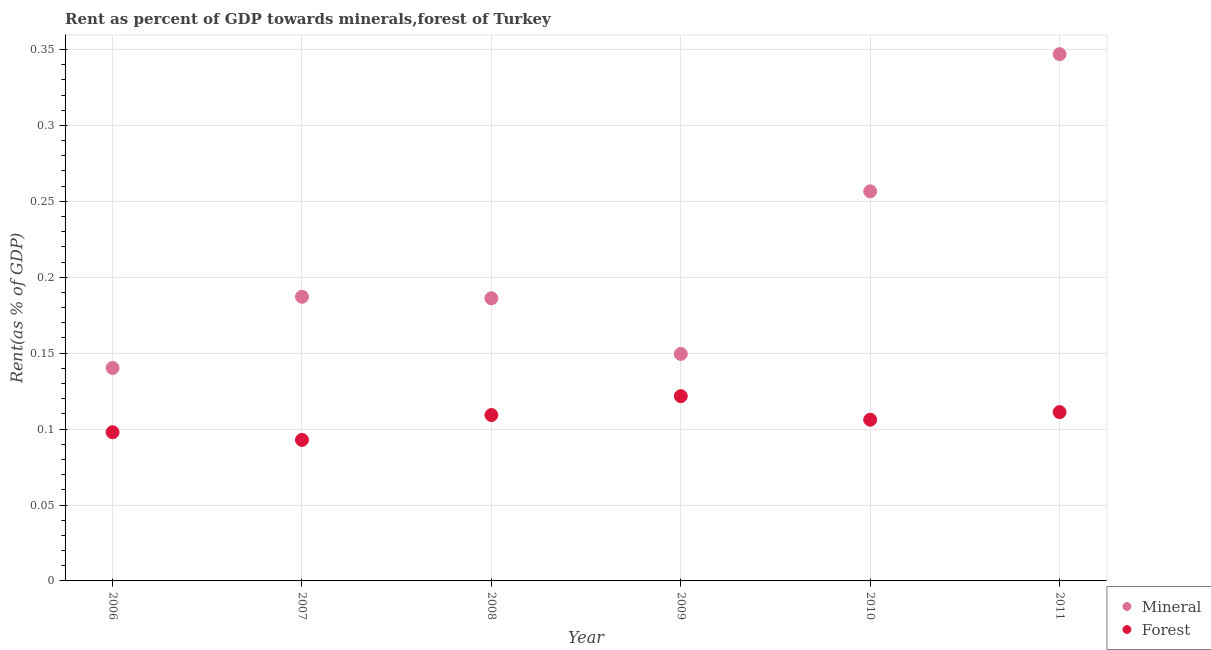How many different coloured dotlines are there?
Offer a very short reply. 2. What is the forest rent in 2010?
Ensure brevity in your answer.  0.11. Across all years, what is the maximum mineral rent?
Your response must be concise. 0.35. Across all years, what is the minimum forest rent?
Offer a very short reply. 0.09. In which year was the forest rent maximum?
Your answer should be very brief. 2009. In which year was the forest rent minimum?
Provide a succinct answer. 2007. What is the total forest rent in the graph?
Give a very brief answer. 0.64. What is the difference between the mineral rent in 2006 and that in 2007?
Give a very brief answer. -0.05. What is the difference between the forest rent in 2006 and the mineral rent in 2008?
Your response must be concise. -0.09. What is the average mineral rent per year?
Provide a succinct answer. 0.21. In the year 2008, what is the difference between the forest rent and mineral rent?
Keep it short and to the point. -0.08. What is the ratio of the mineral rent in 2006 to that in 2010?
Offer a terse response. 0.55. What is the difference between the highest and the second highest forest rent?
Make the answer very short. 0.01. What is the difference between the highest and the lowest forest rent?
Offer a very short reply. 0.03. In how many years, is the mineral rent greater than the average mineral rent taken over all years?
Offer a very short reply. 2. Is the sum of the forest rent in 2009 and 2011 greater than the maximum mineral rent across all years?
Give a very brief answer. No. Is the mineral rent strictly greater than the forest rent over the years?
Provide a short and direct response. Yes. What is the difference between two consecutive major ticks on the Y-axis?
Provide a short and direct response. 0.05. Are the values on the major ticks of Y-axis written in scientific E-notation?
Provide a short and direct response. No. Does the graph contain any zero values?
Offer a very short reply. No. Where does the legend appear in the graph?
Offer a terse response. Bottom right. How many legend labels are there?
Provide a succinct answer. 2. What is the title of the graph?
Keep it short and to the point. Rent as percent of GDP towards minerals,forest of Turkey. Does "Nonresident" appear as one of the legend labels in the graph?
Offer a terse response. No. What is the label or title of the Y-axis?
Provide a short and direct response. Rent(as % of GDP). What is the Rent(as % of GDP) of Mineral in 2006?
Make the answer very short. 0.14. What is the Rent(as % of GDP) of Forest in 2006?
Keep it short and to the point. 0.1. What is the Rent(as % of GDP) of Mineral in 2007?
Your answer should be compact. 0.19. What is the Rent(as % of GDP) of Forest in 2007?
Your answer should be very brief. 0.09. What is the Rent(as % of GDP) in Mineral in 2008?
Make the answer very short. 0.19. What is the Rent(as % of GDP) of Forest in 2008?
Offer a very short reply. 0.11. What is the Rent(as % of GDP) of Mineral in 2009?
Your answer should be compact. 0.15. What is the Rent(as % of GDP) in Forest in 2009?
Offer a terse response. 0.12. What is the Rent(as % of GDP) of Mineral in 2010?
Your answer should be very brief. 0.26. What is the Rent(as % of GDP) in Forest in 2010?
Provide a succinct answer. 0.11. What is the Rent(as % of GDP) of Mineral in 2011?
Your answer should be compact. 0.35. What is the Rent(as % of GDP) of Forest in 2011?
Offer a terse response. 0.11. Across all years, what is the maximum Rent(as % of GDP) in Mineral?
Your answer should be very brief. 0.35. Across all years, what is the maximum Rent(as % of GDP) of Forest?
Provide a succinct answer. 0.12. Across all years, what is the minimum Rent(as % of GDP) in Mineral?
Your answer should be very brief. 0.14. Across all years, what is the minimum Rent(as % of GDP) of Forest?
Your answer should be very brief. 0.09. What is the total Rent(as % of GDP) in Mineral in the graph?
Your response must be concise. 1.27. What is the total Rent(as % of GDP) of Forest in the graph?
Give a very brief answer. 0.64. What is the difference between the Rent(as % of GDP) in Mineral in 2006 and that in 2007?
Offer a very short reply. -0.05. What is the difference between the Rent(as % of GDP) of Forest in 2006 and that in 2007?
Offer a terse response. 0.01. What is the difference between the Rent(as % of GDP) in Mineral in 2006 and that in 2008?
Offer a very short reply. -0.05. What is the difference between the Rent(as % of GDP) of Forest in 2006 and that in 2008?
Offer a very short reply. -0.01. What is the difference between the Rent(as % of GDP) in Mineral in 2006 and that in 2009?
Keep it short and to the point. -0.01. What is the difference between the Rent(as % of GDP) in Forest in 2006 and that in 2009?
Your response must be concise. -0.02. What is the difference between the Rent(as % of GDP) of Mineral in 2006 and that in 2010?
Your response must be concise. -0.12. What is the difference between the Rent(as % of GDP) of Forest in 2006 and that in 2010?
Ensure brevity in your answer.  -0.01. What is the difference between the Rent(as % of GDP) of Mineral in 2006 and that in 2011?
Provide a succinct answer. -0.21. What is the difference between the Rent(as % of GDP) of Forest in 2006 and that in 2011?
Your response must be concise. -0.01. What is the difference between the Rent(as % of GDP) in Mineral in 2007 and that in 2008?
Your answer should be very brief. 0. What is the difference between the Rent(as % of GDP) of Forest in 2007 and that in 2008?
Ensure brevity in your answer.  -0.02. What is the difference between the Rent(as % of GDP) of Mineral in 2007 and that in 2009?
Offer a terse response. 0.04. What is the difference between the Rent(as % of GDP) of Forest in 2007 and that in 2009?
Your answer should be compact. -0.03. What is the difference between the Rent(as % of GDP) of Mineral in 2007 and that in 2010?
Give a very brief answer. -0.07. What is the difference between the Rent(as % of GDP) in Forest in 2007 and that in 2010?
Your response must be concise. -0.01. What is the difference between the Rent(as % of GDP) of Mineral in 2007 and that in 2011?
Provide a short and direct response. -0.16. What is the difference between the Rent(as % of GDP) of Forest in 2007 and that in 2011?
Offer a terse response. -0.02. What is the difference between the Rent(as % of GDP) of Mineral in 2008 and that in 2009?
Your response must be concise. 0.04. What is the difference between the Rent(as % of GDP) in Forest in 2008 and that in 2009?
Give a very brief answer. -0.01. What is the difference between the Rent(as % of GDP) in Mineral in 2008 and that in 2010?
Offer a terse response. -0.07. What is the difference between the Rent(as % of GDP) of Forest in 2008 and that in 2010?
Offer a very short reply. 0. What is the difference between the Rent(as % of GDP) of Mineral in 2008 and that in 2011?
Give a very brief answer. -0.16. What is the difference between the Rent(as % of GDP) in Forest in 2008 and that in 2011?
Make the answer very short. -0. What is the difference between the Rent(as % of GDP) of Mineral in 2009 and that in 2010?
Your response must be concise. -0.11. What is the difference between the Rent(as % of GDP) in Forest in 2009 and that in 2010?
Give a very brief answer. 0.02. What is the difference between the Rent(as % of GDP) in Mineral in 2009 and that in 2011?
Make the answer very short. -0.2. What is the difference between the Rent(as % of GDP) of Forest in 2009 and that in 2011?
Offer a terse response. 0.01. What is the difference between the Rent(as % of GDP) in Mineral in 2010 and that in 2011?
Give a very brief answer. -0.09. What is the difference between the Rent(as % of GDP) in Forest in 2010 and that in 2011?
Provide a short and direct response. -0.01. What is the difference between the Rent(as % of GDP) in Mineral in 2006 and the Rent(as % of GDP) in Forest in 2007?
Your answer should be very brief. 0.05. What is the difference between the Rent(as % of GDP) of Mineral in 2006 and the Rent(as % of GDP) of Forest in 2008?
Keep it short and to the point. 0.03. What is the difference between the Rent(as % of GDP) of Mineral in 2006 and the Rent(as % of GDP) of Forest in 2009?
Ensure brevity in your answer.  0.02. What is the difference between the Rent(as % of GDP) in Mineral in 2006 and the Rent(as % of GDP) in Forest in 2010?
Give a very brief answer. 0.03. What is the difference between the Rent(as % of GDP) of Mineral in 2006 and the Rent(as % of GDP) of Forest in 2011?
Offer a very short reply. 0.03. What is the difference between the Rent(as % of GDP) of Mineral in 2007 and the Rent(as % of GDP) of Forest in 2008?
Your response must be concise. 0.08. What is the difference between the Rent(as % of GDP) of Mineral in 2007 and the Rent(as % of GDP) of Forest in 2009?
Provide a short and direct response. 0.07. What is the difference between the Rent(as % of GDP) in Mineral in 2007 and the Rent(as % of GDP) in Forest in 2010?
Keep it short and to the point. 0.08. What is the difference between the Rent(as % of GDP) in Mineral in 2007 and the Rent(as % of GDP) in Forest in 2011?
Provide a short and direct response. 0.08. What is the difference between the Rent(as % of GDP) of Mineral in 2008 and the Rent(as % of GDP) of Forest in 2009?
Provide a short and direct response. 0.06. What is the difference between the Rent(as % of GDP) of Mineral in 2008 and the Rent(as % of GDP) of Forest in 2010?
Make the answer very short. 0.08. What is the difference between the Rent(as % of GDP) of Mineral in 2008 and the Rent(as % of GDP) of Forest in 2011?
Offer a terse response. 0.07. What is the difference between the Rent(as % of GDP) of Mineral in 2009 and the Rent(as % of GDP) of Forest in 2010?
Offer a terse response. 0.04. What is the difference between the Rent(as % of GDP) of Mineral in 2009 and the Rent(as % of GDP) of Forest in 2011?
Give a very brief answer. 0.04. What is the difference between the Rent(as % of GDP) in Mineral in 2010 and the Rent(as % of GDP) in Forest in 2011?
Your answer should be compact. 0.15. What is the average Rent(as % of GDP) in Mineral per year?
Your answer should be compact. 0.21. What is the average Rent(as % of GDP) in Forest per year?
Give a very brief answer. 0.11. In the year 2006, what is the difference between the Rent(as % of GDP) of Mineral and Rent(as % of GDP) of Forest?
Your answer should be very brief. 0.04. In the year 2007, what is the difference between the Rent(as % of GDP) of Mineral and Rent(as % of GDP) of Forest?
Your answer should be compact. 0.09. In the year 2008, what is the difference between the Rent(as % of GDP) in Mineral and Rent(as % of GDP) in Forest?
Your answer should be compact. 0.08. In the year 2009, what is the difference between the Rent(as % of GDP) in Mineral and Rent(as % of GDP) in Forest?
Keep it short and to the point. 0.03. In the year 2010, what is the difference between the Rent(as % of GDP) of Mineral and Rent(as % of GDP) of Forest?
Offer a very short reply. 0.15. In the year 2011, what is the difference between the Rent(as % of GDP) in Mineral and Rent(as % of GDP) in Forest?
Keep it short and to the point. 0.24. What is the ratio of the Rent(as % of GDP) in Mineral in 2006 to that in 2007?
Give a very brief answer. 0.75. What is the ratio of the Rent(as % of GDP) in Forest in 2006 to that in 2007?
Make the answer very short. 1.05. What is the ratio of the Rent(as % of GDP) of Mineral in 2006 to that in 2008?
Offer a terse response. 0.75. What is the ratio of the Rent(as % of GDP) in Forest in 2006 to that in 2008?
Ensure brevity in your answer.  0.9. What is the ratio of the Rent(as % of GDP) of Mineral in 2006 to that in 2009?
Keep it short and to the point. 0.94. What is the ratio of the Rent(as % of GDP) in Forest in 2006 to that in 2009?
Provide a short and direct response. 0.8. What is the ratio of the Rent(as % of GDP) of Mineral in 2006 to that in 2010?
Give a very brief answer. 0.55. What is the ratio of the Rent(as % of GDP) in Forest in 2006 to that in 2010?
Keep it short and to the point. 0.92. What is the ratio of the Rent(as % of GDP) of Mineral in 2006 to that in 2011?
Provide a succinct answer. 0.4. What is the ratio of the Rent(as % of GDP) of Forest in 2006 to that in 2011?
Offer a very short reply. 0.88. What is the ratio of the Rent(as % of GDP) in Mineral in 2007 to that in 2008?
Ensure brevity in your answer.  1.01. What is the ratio of the Rent(as % of GDP) in Forest in 2007 to that in 2008?
Your response must be concise. 0.85. What is the ratio of the Rent(as % of GDP) of Mineral in 2007 to that in 2009?
Keep it short and to the point. 1.25. What is the ratio of the Rent(as % of GDP) in Forest in 2007 to that in 2009?
Your answer should be compact. 0.76. What is the ratio of the Rent(as % of GDP) of Mineral in 2007 to that in 2010?
Make the answer very short. 0.73. What is the ratio of the Rent(as % of GDP) of Forest in 2007 to that in 2010?
Keep it short and to the point. 0.87. What is the ratio of the Rent(as % of GDP) in Mineral in 2007 to that in 2011?
Your response must be concise. 0.54. What is the ratio of the Rent(as % of GDP) in Forest in 2007 to that in 2011?
Keep it short and to the point. 0.84. What is the ratio of the Rent(as % of GDP) of Mineral in 2008 to that in 2009?
Offer a very short reply. 1.25. What is the ratio of the Rent(as % of GDP) of Forest in 2008 to that in 2009?
Your response must be concise. 0.9. What is the ratio of the Rent(as % of GDP) of Mineral in 2008 to that in 2010?
Provide a short and direct response. 0.73. What is the ratio of the Rent(as % of GDP) of Forest in 2008 to that in 2010?
Ensure brevity in your answer.  1.03. What is the ratio of the Rent(as % of GDP) in Mineral in 2008 to that in 2011?
Provide a succinct answer. 0.54. What is the ratio of the Rent(as % of GDP) in Forest in 2008 to that in 2011?
Offer a very short reply. 0.98. What is the ratio of the Rent(as % of GDP) of Mineral in 2009 to that in 2010?
Keep it short and to the point. 0.58. What is the ratio of the Rent(as % of GDP) of Forest in 2009 to that in 2010?
Provide a succinct answer. 1.15. What is the ratio of the Rent(as % of GDP) in Mineral in 2009 to that in 2011?
Keep it short and to the point. 0.43. What is the ratio of the Rent(as % of GDP) of Forest in 2009 to that in 2011?
Ensure brevity in your answer.  1.09. What is the ratio of the Rent(as % of GDP) in Mineral in 2010 to that in 2011?
Your answer should be very brief. 0.74. What is the ratio of the Rent(as % of GDP) of Forest in 2010 to that in 2011?
Ensure brevity in your answer.  0.95. What is the difference between the highest and the second highest Rent(as % of GDP) in Mineral?
Ensure brevity in your answer.  0.09. What is the difference between the highest and the second highest Rent(as % of GDP) in Forest?
Ensure brevity in your answer.  0.01. What is the difference between the highest and the lowest Rent(as % of GDP) of Mineral?
Your answer should be compact. 0.21. What is the difference between the highest and the lowest Rent(as % of GDP) in Forest?
Make the answer very short. 0.03. 